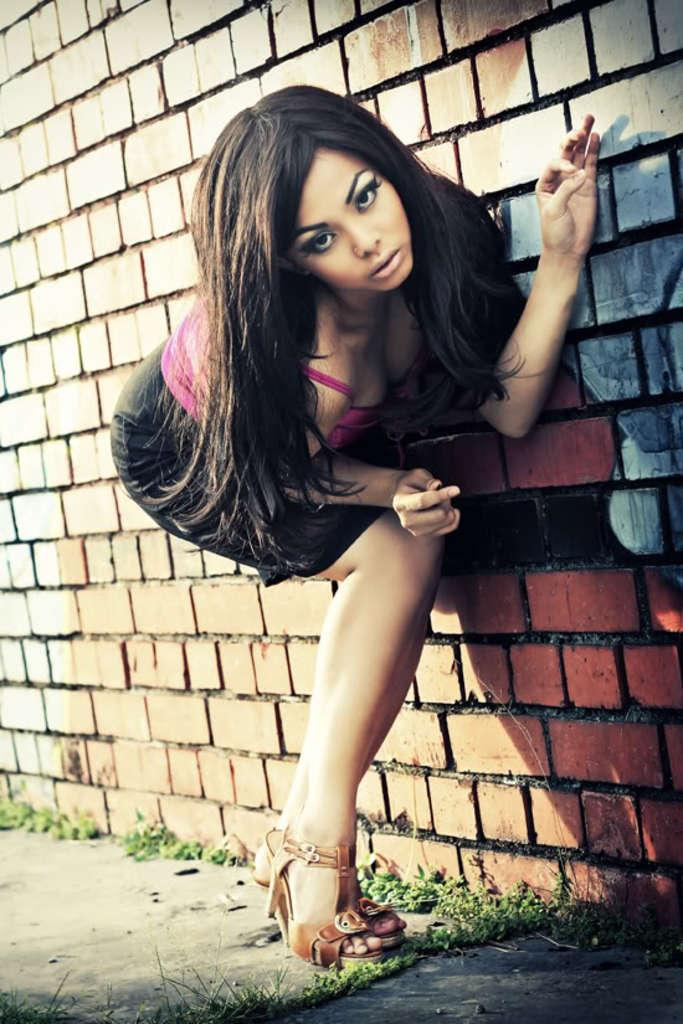Who is present in the image? There is a woman in the image. What is the woman wearing? The woman is wearing clothes and sandals. What type of surface can be seen in the image? There is a brick wall, grass, and a footpath in the image. How many boats are visible in the image? There are no boats present in the image. What is the woman's state of mind in the image? The image does not provide any information about the woman's state of mind. 